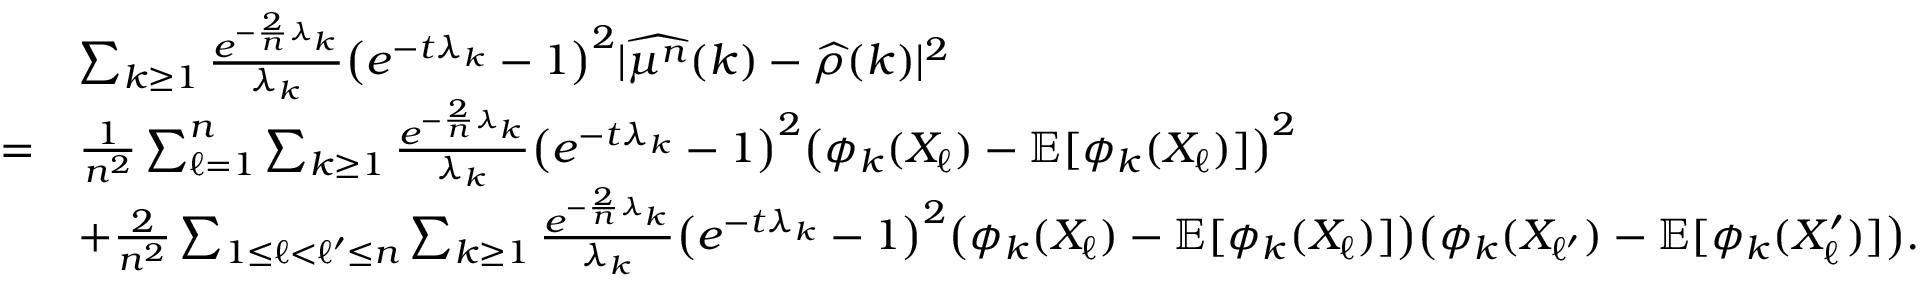Convert formula to latex. <formula><loc_0><loc_0><loc_500><loc_500>\begin{array} { r l } & { \sum _ { k \geq 1 } \frac { e ^ { - \frac { 2 } { n } \lambda _ { k } } } { \lambda _ { k } } \left ( e ^ { - t \lambda _ { k } } - 1 \right ) ^ { 2 } | \widehat { \mu ^ { n } } ( k ) - \widehat { \rho } ( k ) | ^ { 2 } } \\ { = } & { \frac { 1 } { n ^ { 2 } } \sum _ { \ell = 1 } ^ { n } \sum _ { k \geq 1 } \frac { e ^ { - \frac { 2 } { n } \lambda _ { k } } } { \lambda _ { k } } \left ( e ^ { - t \lambda _ { k } } - 1 \right ) ^ { 2 } \left ( \phi _ { k } ( X _ { \ell } ) - \mathbb { E } [ \phi _ { k } ( X _ { \ell } ) ] \right ) ^ { 2 } } \\ & { + \frac { 2 } { n ^ { 2 } } \sum _ { 1 \leq \ell < \ell ^ { \prime } \leq n } \sum _ { k \geq 1 } \frac { e ^ { - \frac { 2 } { n } \lambda _ { k } } } { \lambda _ { k } } \left ( e ^ { - t \lambda _ { k } } - 1 \right ) ^ { 2 } \left ( \phi _ { k } ( X _ { \ell } ) - \mathbb { E } [ \phi _ { k } ( X _ { \ell } ) ] \right ) \left ( \phi _ { k } ( X _ { \ell ^ { \prime } } ) - \mathbb { E } [ \phi _ { k } ( X _ { \ell } ^ { \prime } ) ] \right ) . } \end{array}</formula> 